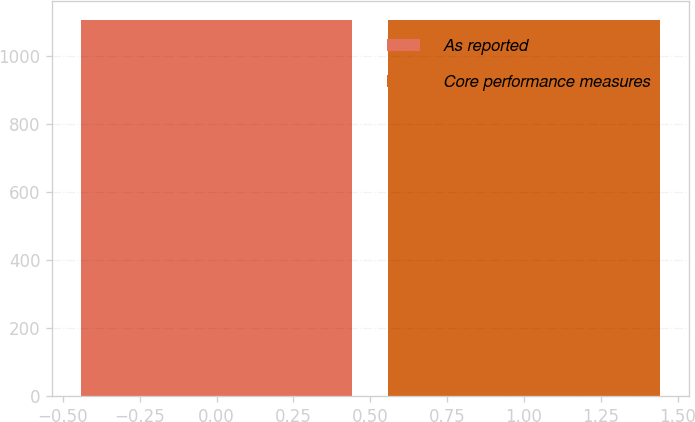<chart> <loc_0><loc_0><loc_500><loc_500><bar_chart><fcel>As reported<fcel>Core performance measures<nl><fcel>1107<fcel>1107.1<nl></chart> 